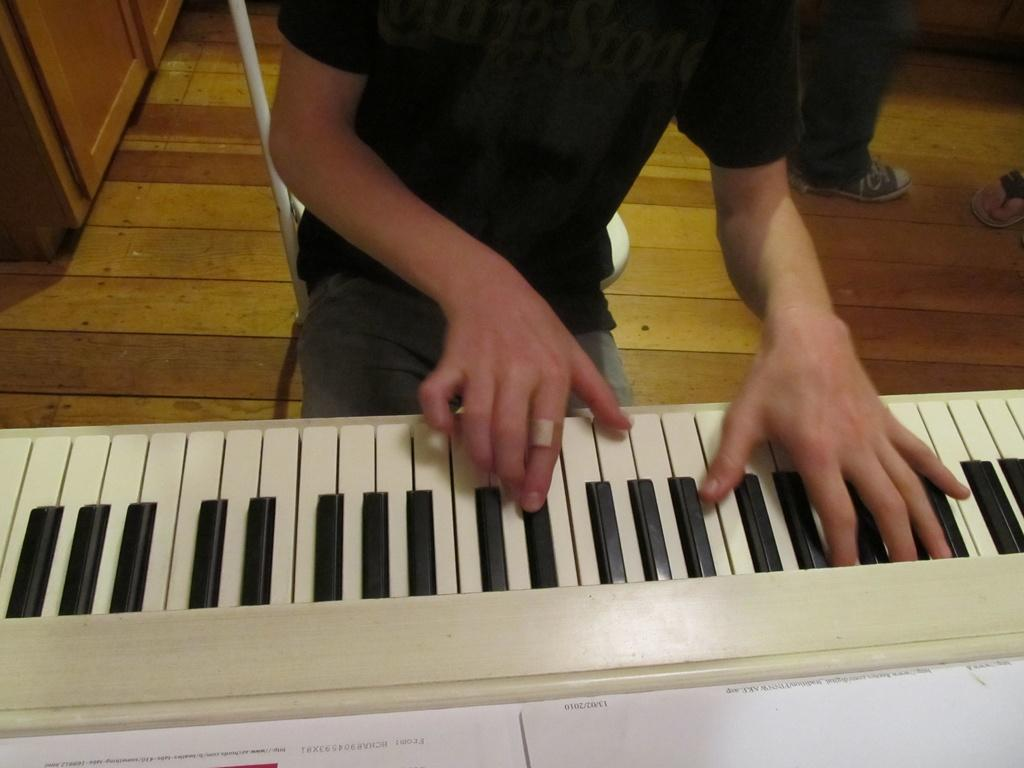What is the main activity being performed in the image? There is a person playing a keyboard in the image. Can you describe any other people present in the image? The legs of two other persons are visible in the image. What type of bells can be heard ringing in the background of the image? There is no mention of bells or any sound in the image, so it is not possible to determine if any bells are ringing. 